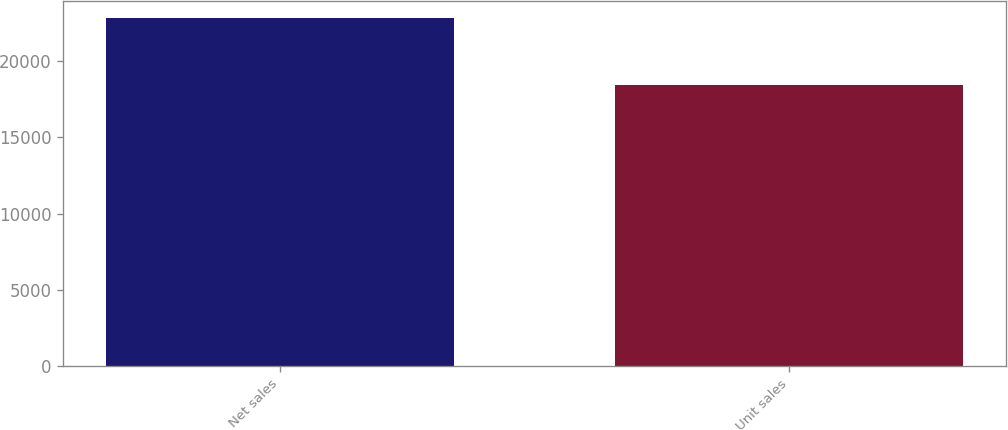Convert chart to OTSL. <chart><loc_0><loc_0><loc_500><loc_500><bar_chart><fcel>Net sales<fcel>Unit sales<nl><fcel>22831<fcel>18484<nl></chart> 